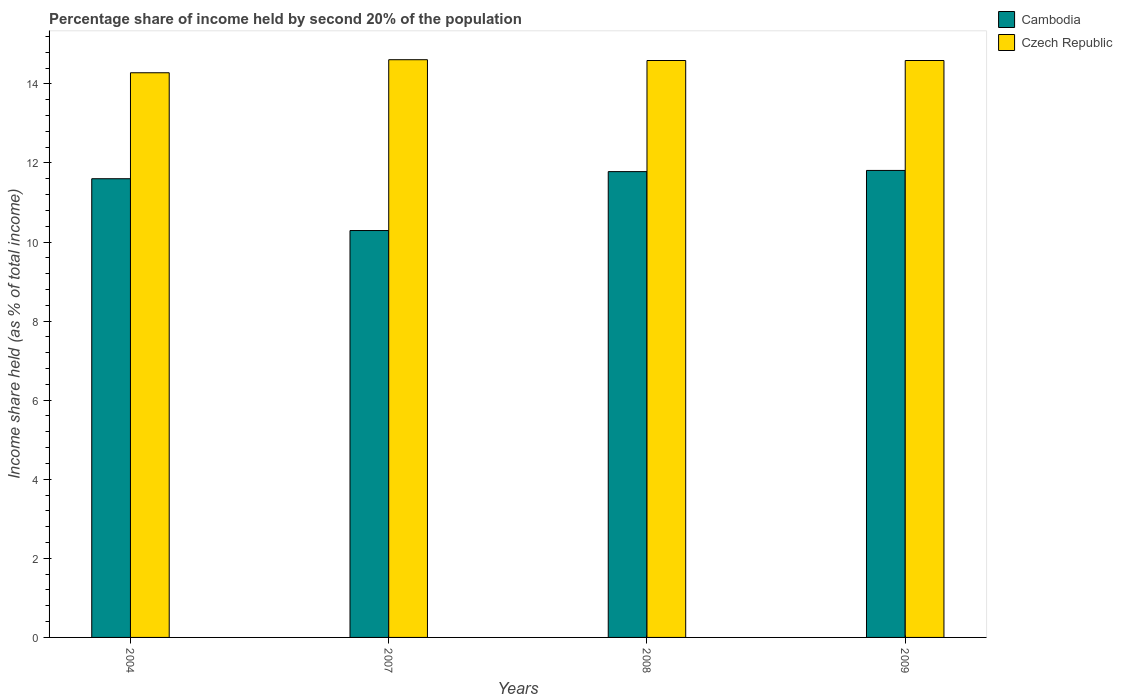How many different coloured bars are there?
Give a very brief answer. 2. How many groups of bars are there?
Offer a very short reply. 4. How many bars are there on the 3rd tick from the left?
Offer a very short reply. 2. What is the share of income held by second 20% of the population in Cambodia in 2009?
Keep it short and to the point. 11.81. Across all years, what is the maximum share of income held by second 20% of the population in Cambodia?
Your response must be concise. 11.81. Across all years, what is the minimum share of income held by second 20% of the population in Cambodia?
Your answer should be very brief. 10.29. In which year was the share of income held by second 20% of the population in Cambodia maximum?
Offer a terse response. 2009. In which year was the share of income held by second 20% of the population in Czech Republic minimum?
Ensure brevity in your answer.  2004. What is the total share of income held by second 20% of the population in Cambodia in the graph?
Your response must be concise. 45.48. What is the difference between the share of income held by second 20% of the population in Czech Republic in 2007 and the share of income held by second 20% of the population in Cambodia in 2008?
Give a very brief answer. 2.83. What is the average share of income held by second 20% of the population in Czech Republic per year?
Your response must be concise. 14.52. In the year 2009, what is the difference between the share of income held by second 20% of the population in Cambodia and share of income held by second 20% of the population in Czech Republic?
Your answer should be very brief. -2.78. In how many years, is the share of income held by second 20% of the population in Czech Republic greater than 11.6 %?
Provide a succinct answer. 4. What is the ratio of the share of income held by second 20% of the population in Cambodia in 2004 to that in 2008?
Your answer should be compact. 0.98. Is the difference between the share of income held by second 20% of the population in Cambodia in 2007 and 2008 greater than the difference between the share of income held by second 20% of the population in Czech Republic in 2007 and 2008?
Provide a succinct answer. No. What is the difference between the highest and the second highest share of income held by second 20% of the population in Cambodia?
Your answer should be compact. 0.03. What is the difference between the highest and the lowest share of income held by second 20% of the population in Cambodia?
Provide a succinct answer. 1.52. What does the 1st bar from the left in 2009 represents?
Offer a terse response. Cambodia. What does the 2nd bar from the right in 2004 represents?
Provide a short and direct response. Cambodia. How many bars are there?
Your response must be concise. 8. How many years are there in the graph?
Offer a very short reply. 4. What is the difference between two consecutive major ticks on the Y-axis?
Offer a terse response. 2. Are the values on the major ticks of Y-axis written in scientific E-notation?
Keep it short and to the point. No. Does the graph contain any zero values?
Offer a terse response. No. Does the graph contain grids?
Your response must be concise. No. How are the legend labels stacked?
Offer a terse response. Vertical. What is the title of the graph?
Offer a terse response. Percentage share of income held by second 20% of the population. What is the label or title of the X-axis?
Your answer should be very brief. Years. What is the label or title of the Y-axis?
Your answer should be compact. Income share held (as % of total income). What is the Income share held (as % of total income) in Czech Republic in 2004?
Offer a terse response. 14.28. What is the Income share held (as % of total income) of Cambodia in 2007?
Provide a succinct answer. 10.29. What is the Income share held (as % of total income) of Czech Republic in 2007?
Your answer should be compact. 14.61. What is the Income share held (as % of total income) of Cambodia in 2008?
Offer a terse response. 11.78. What is the Income share held (as % of total income) of Czech Republic in 2008?
Your answer should be very brief. 14.59. What is the Income share held (as % of total income) in Cambodia in 2009?
Offer a very short reply. 11.81. What is the Income share held (as % of total income) in Czech Republic in 2009?
Your response must be concise. 14.59. Across all years, what is the maximum Income share held (as % of total income) of Cambodia?
Make the answer very short. 11.81. Across all years, what is the maximum Income share held (as % of total income) of Czech Republic?
Your answer should be very brief. 14.61. Across all years, what is the minimum Income share held (as % of total income) in Cambodia?
Your answer should be compact. 10.29. Across all years, what is the minimum Income share held (as % of total income) in Czech Republic?
Offer a very short reply. 14.28. What is the total Income share held (as % of total income) of Cambodia in the graph?
Keep it short and to the point. 45.48. What is the total Income share held (as % of total income) in Czech Republic in the graph?
Keep it short and to the point. 58.07. What is the difference between the Income share held (as % of total income) in Cambodia in 2004 and that in 2007?
Provide a succinct answer. 1.31. What is the difference between the Income share held (as % of total income) in Czech Republic in 2004 and that in 2007?
Your answer should be very brief. -0.33. What is the difference between the Income share held (as % of total income) in Cambodia in 2004 and that in 2008?
Give a very brief answer. -0.18. What is the difference between the Income share held (as % of total income) of Czech Republic in 2004 and that in 2008?
Give a very brief answer. -0.31. What is the difference between the Income share held (as % of total income) of Cambodia in 2004 and that in 2009?
Offer a very short reply. -0.21. What is the difference between the Income share held (as % of total income) of Czech Republic in 2004 and that in 2009?
Provide a short and direct response. -0.31. What is the difference between the Income share held (as % of total income) in Cambodia in 2007 and that in 2008?
Your answer should be very brief. -1.49. What is the difference between the Income share held (as % of total income) of Cambodia in 2007 and that in 2009?
Your response must be concise. -1.52. What is the difference between the Income share held (as % of total income) in Cambodia in 2008 and that in 2009?
Your answer should be compact. -0.03. What is the difference between the Income share held (as % of total income) of Cambodia in 2004 and the Income share held (as % of total income) of Czech Republic in 2007?
Your response must be concise. -3.01. What is the difference between the Income share held (as % of total income) of Cambodia in 2004 and the Income share held (as % of total income) of Czech Republic in 2008?
Give a very brief answer. -2.99. What is the difference between the Income share held (as % of total income) of Cambodia in 2004 and the Income share held (as % of total income) of Czech Republic in 2009?
Your answer should be very brief. -2.99. What is the difference between the Income share held (as % of total income) of Cambodia in 2007 and the Income share held (as % of total income) of Czech Republic in 2009?
Give a very brief answer. -4.3. What is the difference between the Income share held (as % of total income) in Cambodia in 2008 and the Income share held (as % of total income) in Czech Republic in 2009?
Provide a succinct answer. -2.81. What is the average Income share held (as % of total income) of Cambodia per year?
Offer a terse response. 11.37. What is the average Income share held (as % of total income) of Czech Republic per year?
Make the answer very short. 14.52. In the year 2004, what is the difference between the Income share held (as % of total income) of Cambodia and Income share held (as % of total income) of Czech Republic?
Ensure brevity in your answer.  -2.68. In the year 2007, what is the difference between the Income share held (as % of total income) of Cambodia and Income share held (as % of total income) of Czech Republic?
Your answer should be very brief. -4.32. In the year 2008, what is the difference between the Income share held (as % of total income) of Cambodia and Income share held (as % of total income) of Czech Republic?
Make the answer very short. -2.81. In the year 2009, what is the difference between the Income share held (as % of total income) of Cambodia and Income share held (as % of total income) of Czech Republic?
Provide a short and direct response. -2.78. What is the ratio of the Income share held (as % of total income) of Cambodia in 2004 to that in 2007?
Keep it short and to the point. 1.13. What is the ratio of the Income share held (as % of total income) of Czech Republic in 2004 to that in 2007?
Ensure brevity in your answer.  0.98. What is the ratio of the Income share held (as % of total income) of Cambodia in 2004 to that in 2008?
Provide a short and direct response. 0.98. What is the ratio of the Income share held (as % of total income) in Czech Republic in 2004 to that in 2008?
Give a very brief answer. 0.98. What is the ratio of the Income share held (as % of total income) of Cambodia in 2004 to that in 2009?
Make the answer very short. 0.98. What is the ratio of the Income share held (as % of total income) of Czech Republic in 2004 to that in 2009?
Provide a short and direct response. 0.98. What is the ratio of the Income share held (as % of total income) in Cambodia in 2007 to that in 2008?
Provide a short and direct response. 0.87. What is the ratio of the Income share held (as % of total income) in Czech Republic in 2007 to that in 2008?
Your response must be concise. 1. What is the ratio of the Income share held (as % of total income) of Cambodia in 2007 to that in 2009?
Ensure brevity in your answer.  0.87. What is the difference between the highest and the second highest Income share held (as % of total income) in Cambodia?
Provide a succinct answer. 0.03. What is the difference between the highest and the second highest Income share held (as % of total income) of Czech Republic?
Offer a terse response. 0.02. What is the difference between the highest and the lowest Income share held (as % of total income) in Cambodia?
Ensure brevity in your answer.  1.52. What is the difference between the highest and the lowest Income share held (as % of total income) of Czech Republic?
Offer a terse response. 0.33. 